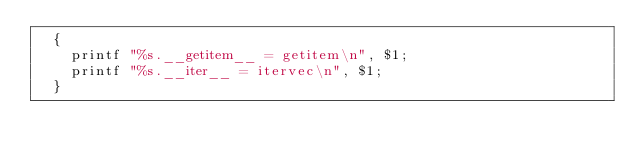Convert code to text. <code><loc_0><loc_0><loc_500><loc_500><_Awk_>  {
	printf "%s.__getitem__ = getitem\n", $1;
	printf "%s.__iter__ = itervec\n", $1;
  }
</code> 